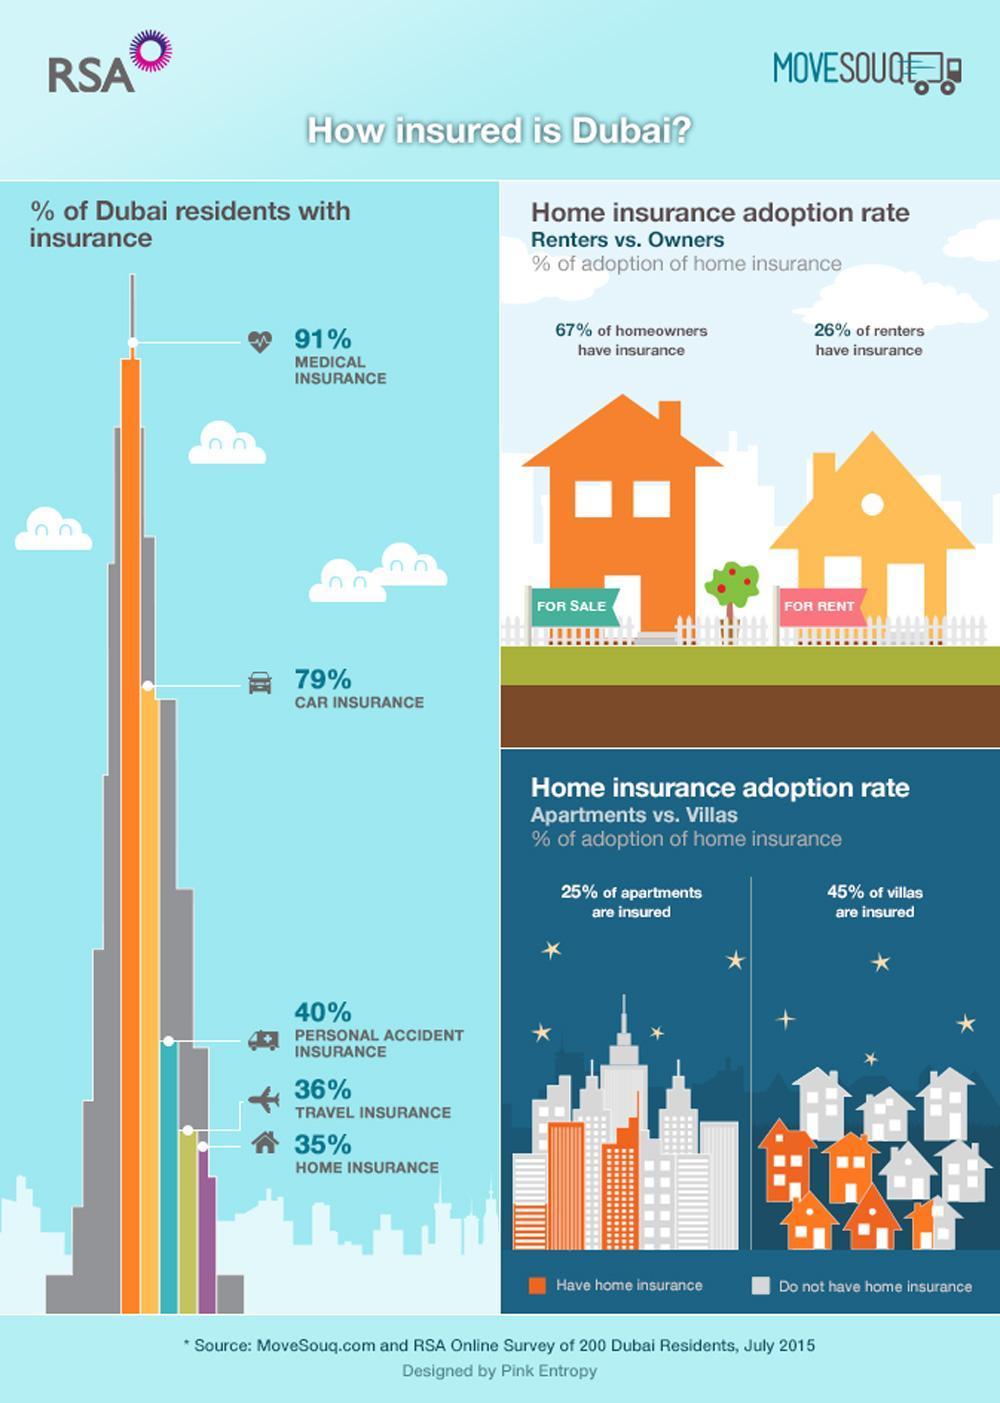What is the color given to Home insurance- red, orange, purple, green?
Answer the question with a short phrase. purple What percentage of people not residing in their own house got insurance? 26% What percentage of people resides in Dubai do not have car insurance? 21 What is the color code given to insured flats and villas- red, orange, yellow, green? orange What percentage of people resides in Dubai do not have health insurance? 9 What percentage of people resides in Dubai do not have travel insurance? 64 Which insurance has the second rank among others? Car Insurance What percentage of people resides in Dubai have injury insurance? 40% What percentage of people resides in Dubai do not have home insurance? 65 What percentage of people residing in their house got insurance? 67% 